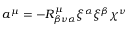Convert formula to latex. <formula><loc_0><loc_0><loc_500><loc_500>a ^ { \mu } = - R _ { \beta \nu \alpha } ^ { \mu } \xi ^ { \alpha } \xi ^ { \beta } \chi ^ { \nu }</formula> 